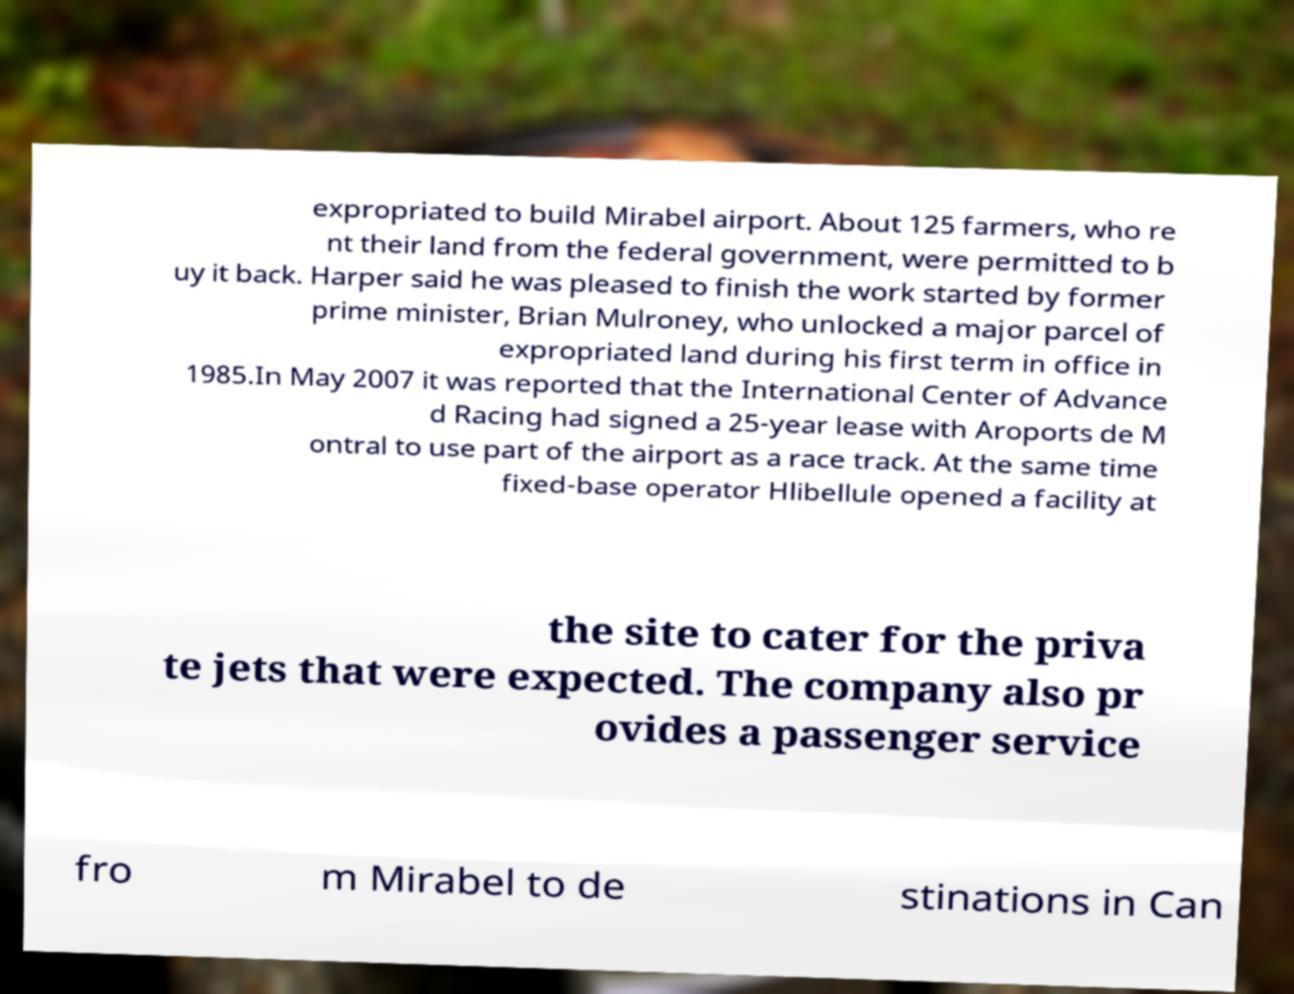Could you assist in decoding the text presented in this image and type it out clearly? expropriated to build Mirabel airport. About 125 farmers, who re nt their land from the federal government, were permitted to b uy it back. Harper said he was pleased to finish the work started by former prime minister, Brian Mulroney, who unlocked a major parcel of expropriated land during his first term in office in 1985.In May 2007 it was reported that the International Center of Advance d Racing had signed a 25-year lease with Aroports de M ontral to use part of the airport as a race track. At the same time fixed-base operator Hlibellule opened a facility at the site to cater for the priva te jets that were expected. The company also pr ovides a passenger service fro m Mirabel to de stinations in Can 